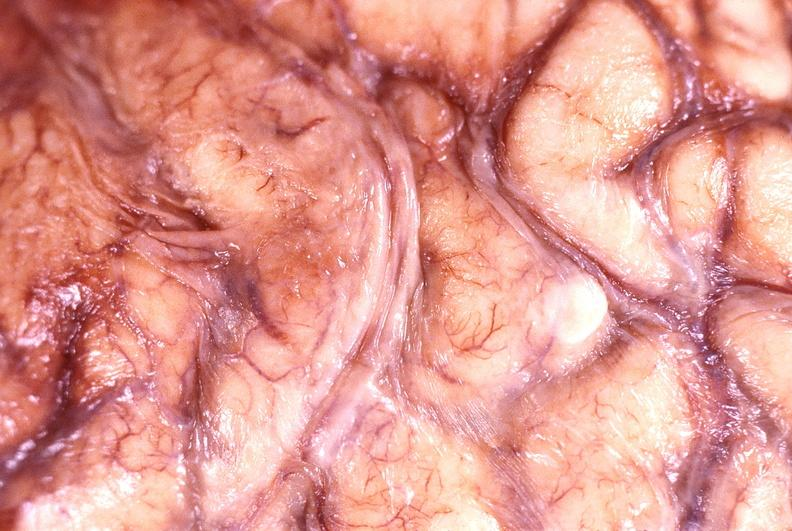what does this image show?
Answer the question using a single word or phrase. Brain abscess 